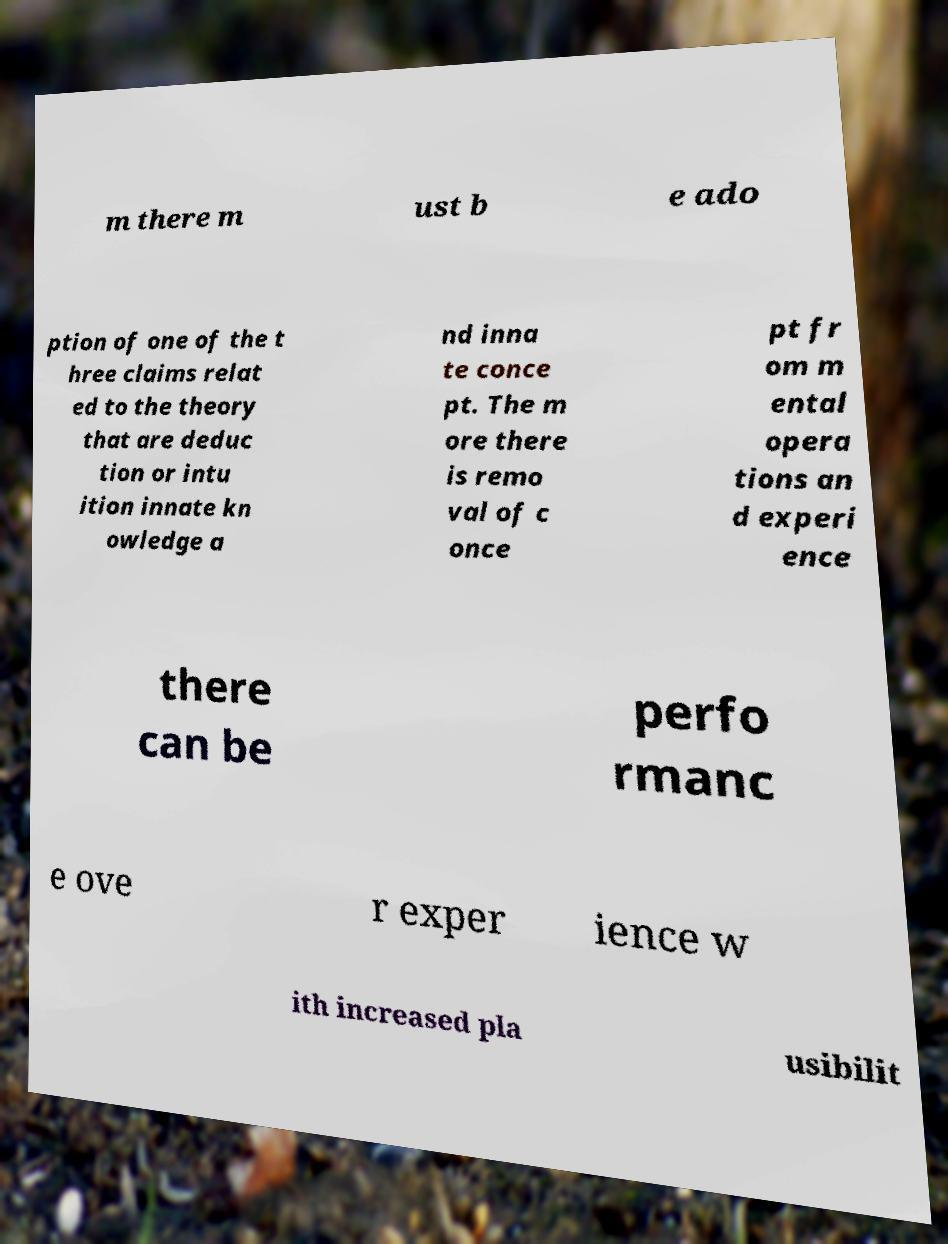Can you read and provide the text displayed in the image?This photo seems to have some interesting text. Can you extract and type it out for me? m there m ust b e ado ption of one of the t hree claims relat ed to the theory that are deduc tion or intu ition innate kn owledge a nd inna te conce pt. The m ore there is remo val of c once pt fr om m ental opera tions an d experi ence there can be perfo rmanc e ove r exper ience w ith increased pla usibilit 